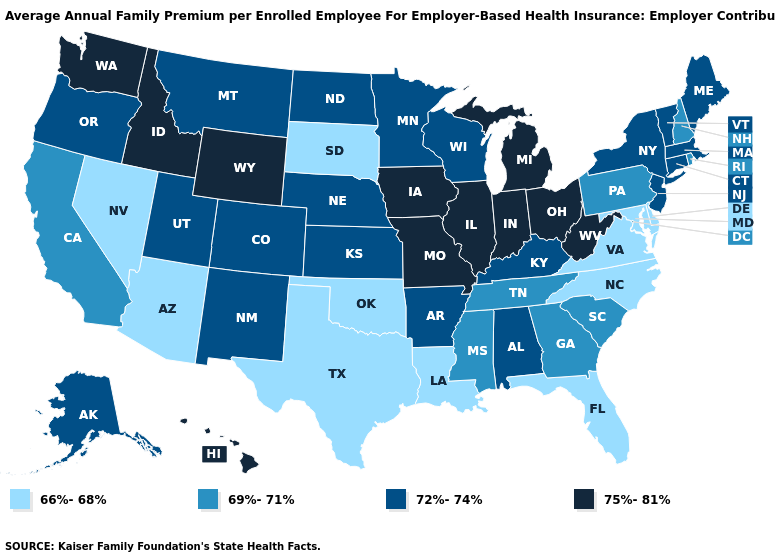Does Ohio have the same value as Washington?
Be succinct. Yes. Does Ohio have the lowest value in the MidWest?
Keep it brief. No. Name the states that have a value in the range 72%-74%?
Short answer required. Alabama, Alaska, Arkansas, Colorado, Connecticut, Kansas, Kentucky, Maine, Massachusetts, Minnesota, Montana, Nebraska, New Jersey, New Mexico, New York, North Dakota, Oregon, Utah, Vermont, Wisconsin. Does Oregon have a lower value than Missouri?
Write a very short answer. Yes. What is the value of Alabama?
Concise answer only. 72%-74%. Which states hav the highest value in the MidWest?
Write a very short answer. Illinois, Indiana, Iowa, Michigan, Missouri, Ohio. What is the lowest value in the USA?
Be succinct. 66%-68%. Name the states that have a value in the range 72%-74%?
Short answer required. Alabama, Alaska, Arkansas, Colorado, Connecticut, Kansas, Kentucky, Maine, Massachusetts, Minnesota, Montana, Nebraska, New Jersey, New Mexico, New York, North Dakota, Oregon, Utah, Vermont, Wisconsin. Name the states that have a value in the range 72%-74%?
Short answer required. Alabama, Alaska, Arkansas, Colorado, Connecticut, Kansas, Kentucky, Maine, Massachusetts, Minnesota, Montana, Nebraska, New Jersey, New Mexico, New York, North Dakota, Oregon, Utah, Vermont, Wisconsin. What is the lowest value in the West?
Short answer required. 66%-68%. Among the states that border Mississippi , which have the lowest value?
Write a very short answer. Louisiana. What is the value of Minnesota?
Keep it brief. 72%-74%. Name the states that have a value in the range 69%-71%?
Be succinct. California, Georgia, Mississippi, New Hampshire, Pennsylvania, Rhode Island, South Carolina, Tennessee. What is the lowest value in the South?
Concise answer only. 66%-68%. What is the value of Nevada?
Write a very short answer. 66%-68%. 